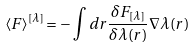Convert formula to latex. <formula><loc_0><loc_0><loc_500><loc_500>\langle { F } \rangle ^ { [ \lambda ] } = - \int d { r } \frac { \delta F _ { [ \lambda ] } } { \delta \lambda ( { r } ) } \nabla \lambda ( { r } )</formula> 